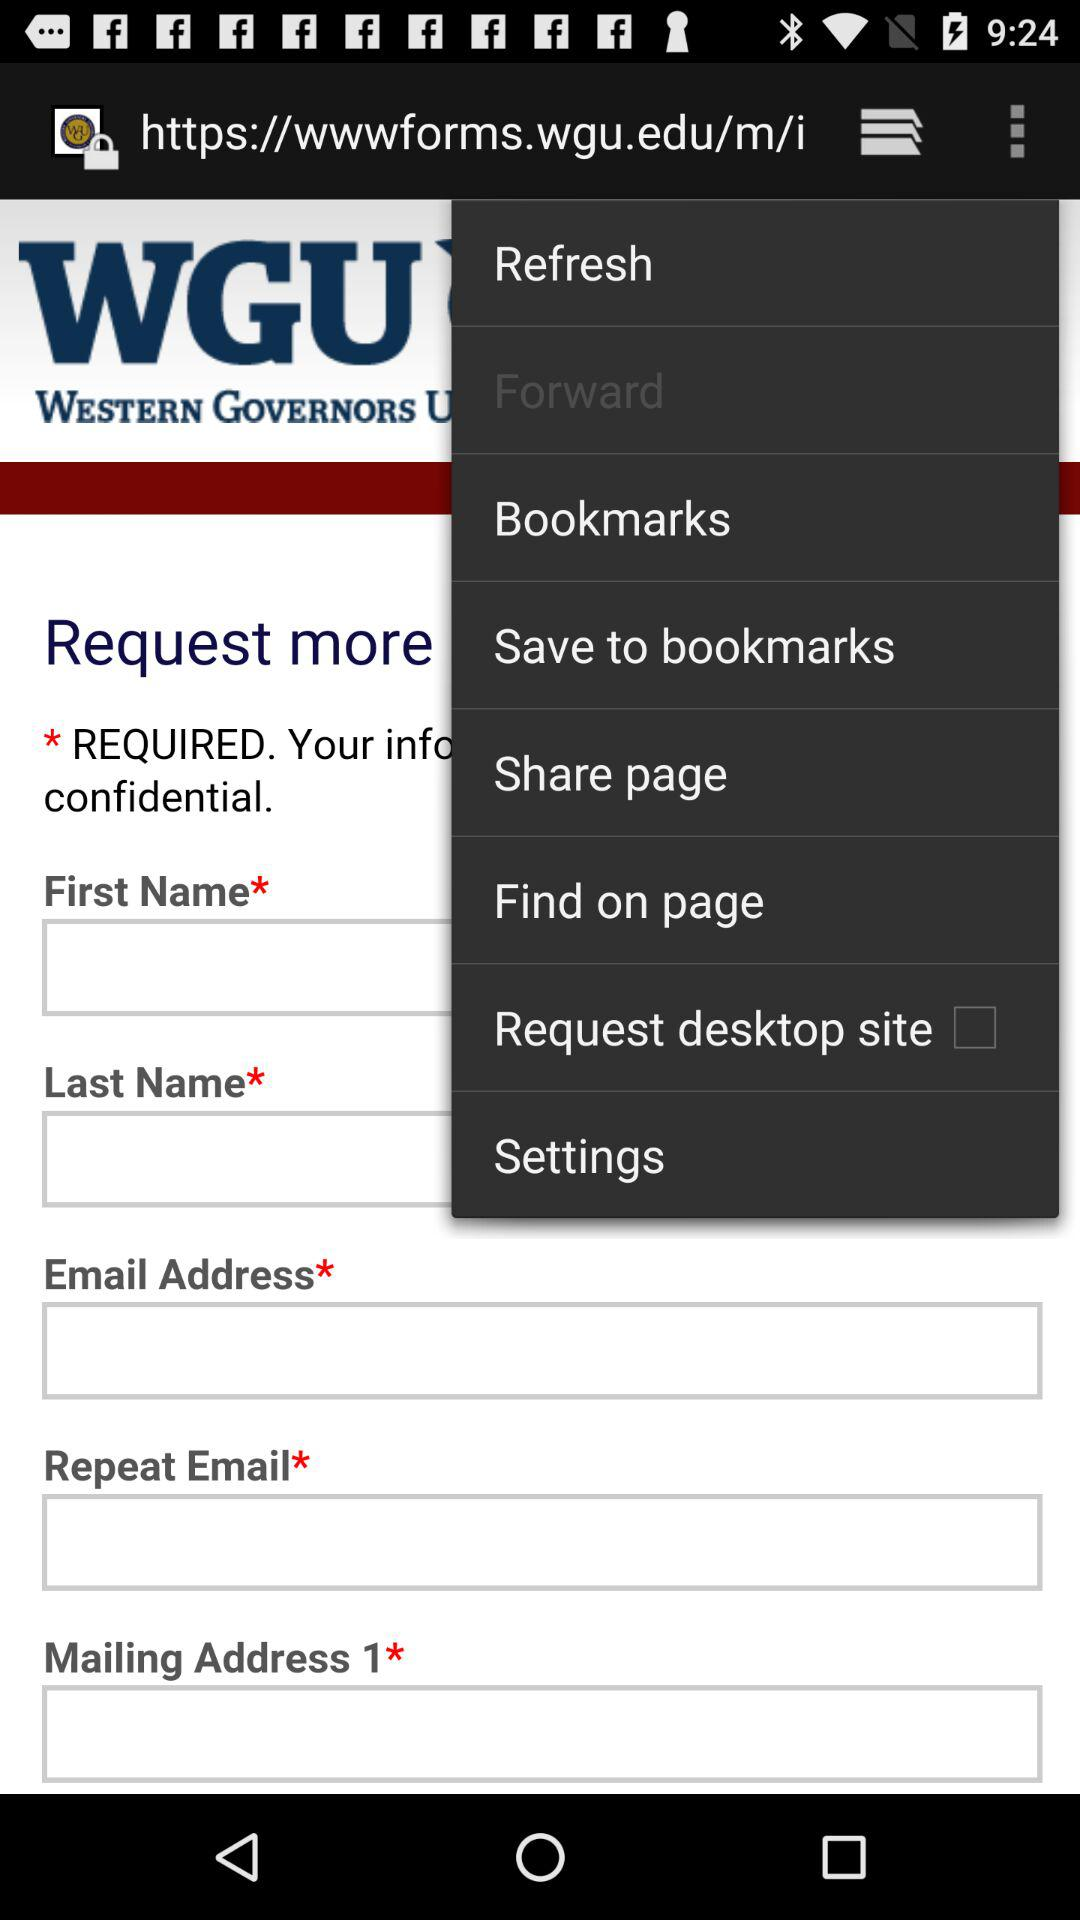How many text input fields are there on the screen?
Answer the question using a single word or phrase. 5 